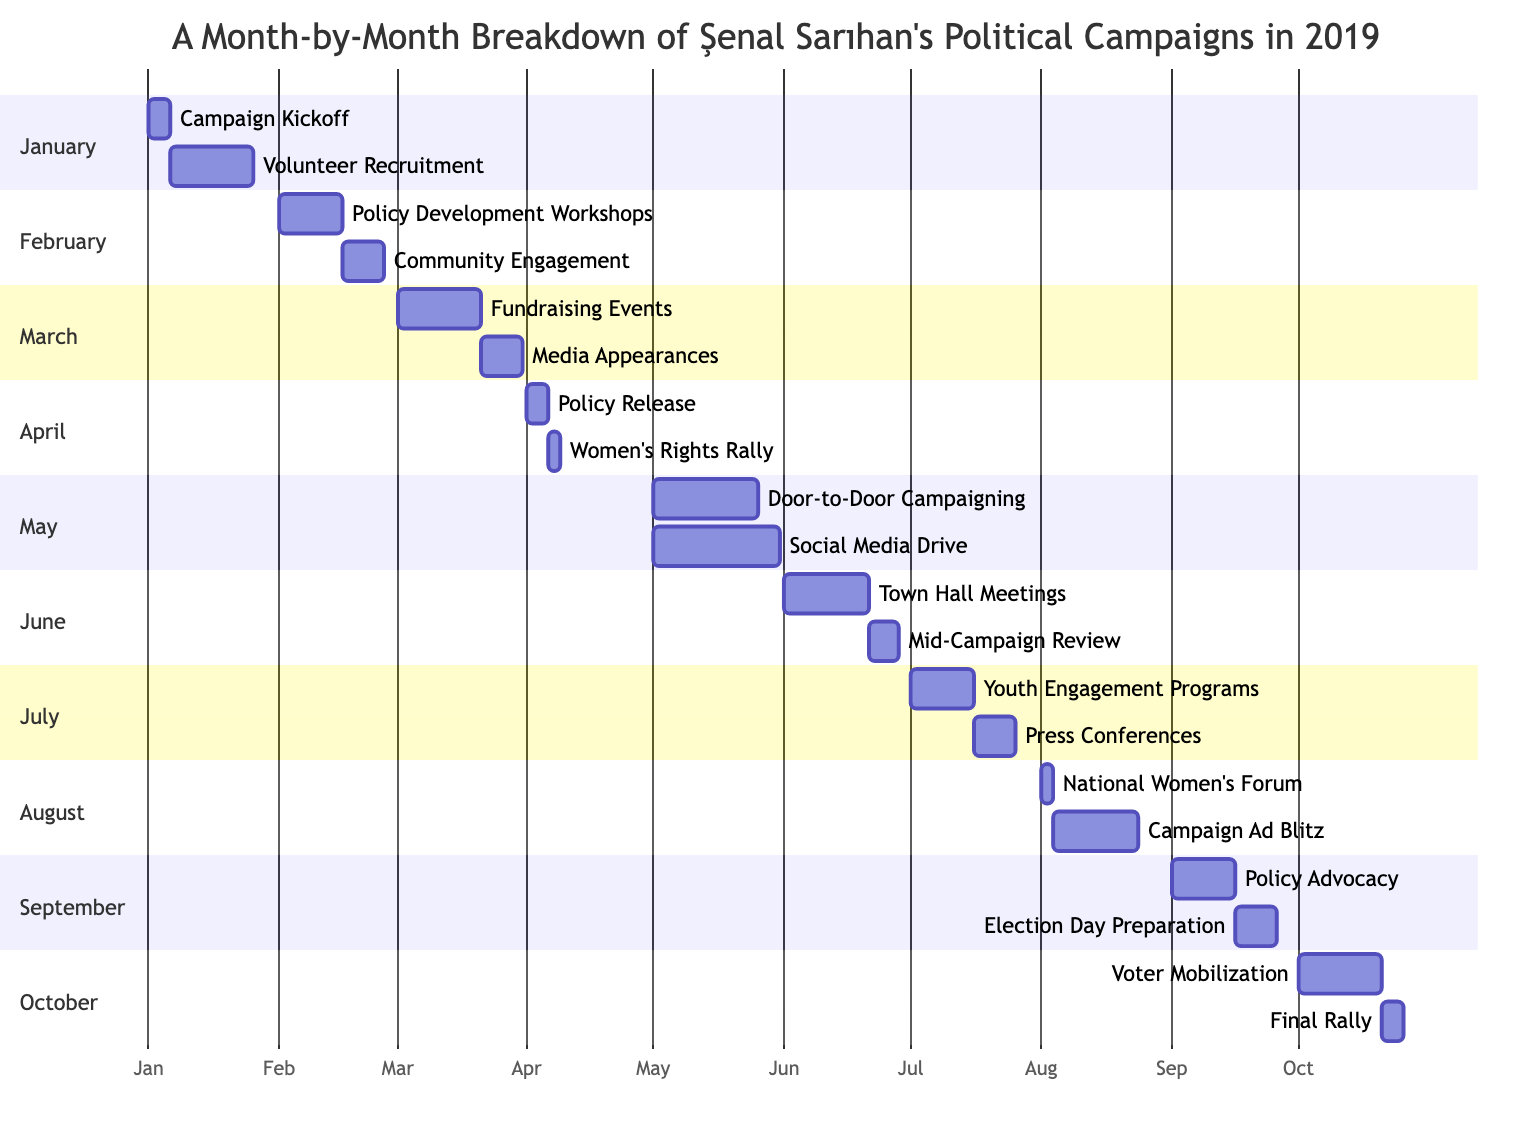What are the two main activities in January? In January, there are two activities: "Campaign Kickoff" and "Volunteer Recruitment." This can be observed by looking at the January section of the Gantt Chart where the activities are listed.
Answer: Campaign Kickoff, Volunteer Recruitment How many days does the "Social Media Drive" last? The "Social Media Drive" lasts for 30 days, as indicated in the May section of the Gantt Chart where the duration next to the activity is displayed.
Answer: 30 days Which month has the "Women's Rights Rally"? The "Women's Rights Rally" is in April, as indicated by the April section of the Gantt Chart where this activity is listed.
Answer: April What are the last two activities in the campaign timeline? The last two activities in the Gantt Chart are "Voter Mobilization" and "Final Rally," found in the October section of the diagram.
Answer: Voter Mobilization, Final Rally Which activity overlaps with "Door-to-Door Campaigning"? The "Social Media Drive" overlaps with "Door-to-Door Campaigning," as both activities start in May according to the Gantt Chart, occurring simultaneously.
Answer: Social Media Drive How long does the "Mid-Campaign Review" take? The "Mid-Campaign Review" takes 7 days, as shown in the June section of the Gantt Chart where its duration is specified.
Answer: 7 days What is the main focus of "Policy Development Workshops"? The main focus of "Policy Development Workshops" is on women's rights and social justice, as described in the corresponding section of the diagram.
Answer: Women's rights and social justice At which point does the campaign review its progress? The campaign reviews its progress during the "Mid-Campaign Review" in June, based on the timeline shown in the Gantt Chart.
Answer: Mid-Campaign Review What is the total duration of activities in October? The total duration of activities in October is 25 days, which includes 20 days for "Voter Mobilization" and 5 days for "Final Rally," as indicated in the October section.
Answer: 25 days 